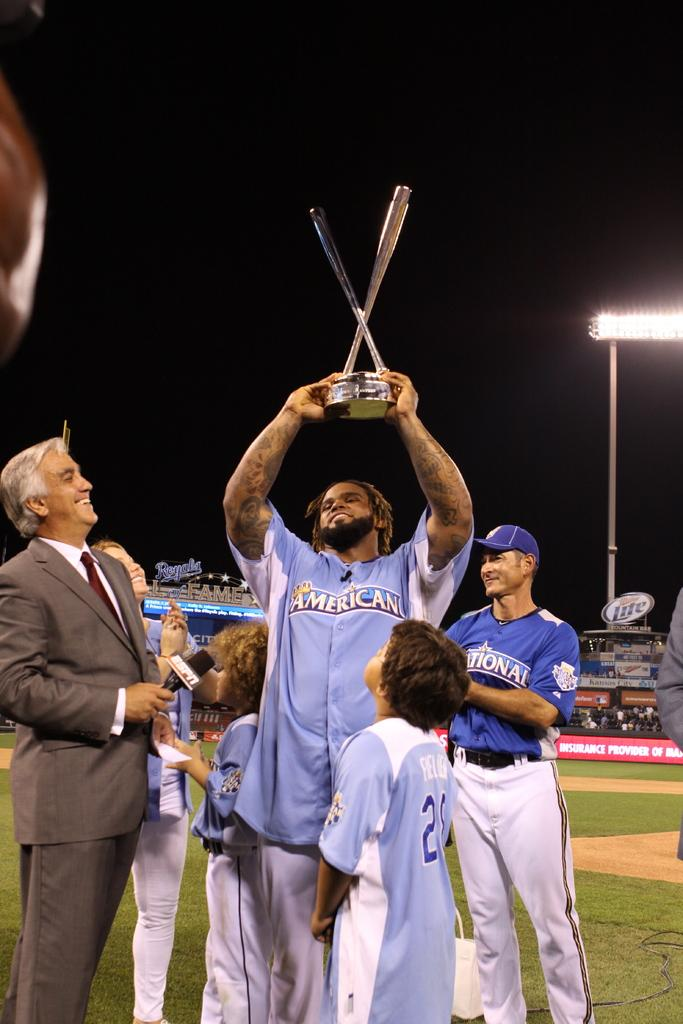<image>
Present a compact description of the photo's key features. Man wearing a jersey that says American holding a trophy. 